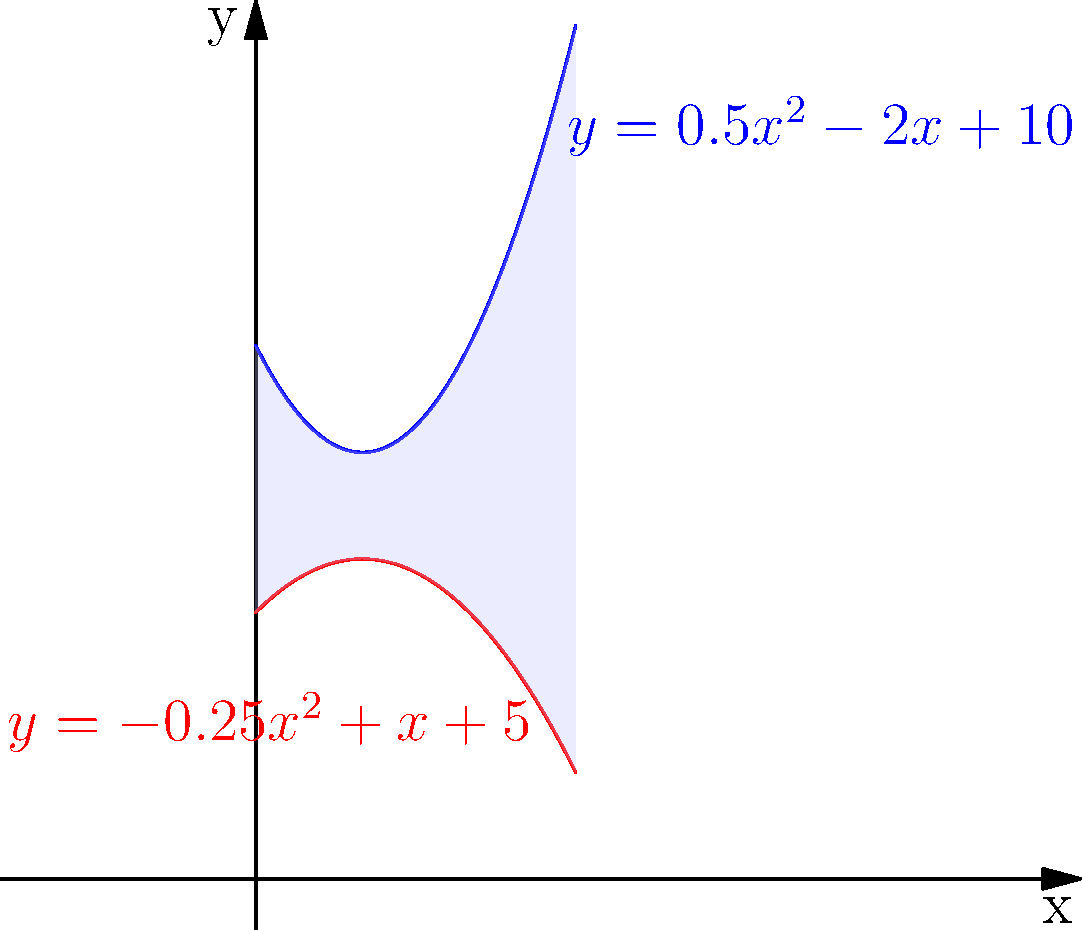The Scone Thistle football pitch has an unusual shape. The groundskeeper measured the width of the pitch at various points along its length and found that it can be modeled by two polynomial functions:

Upper boundary: $y = 0.5x^2 - 2x + 10$
Lower boundary: $y = -0.25x^2 + x + 5$

where $x$ is the distance along the length of the pitch in meters, and $y$ is the half-width of the pitch in meters. If the pitch is 60 meters long, calculate its total area in square meters. To find the area of the pitch, we need to calculate the area between the two curves over the interval $[0, 60]$. This can be done using definite integration.

Step 1: Set up the integral
Area = $\int_0^{60} [(0.5x^2 - 2x + 10) - (-0.25x^2 + x + 5)] dx$

Step 2: Simplify the integrand
$\int_0^{60} (0.5x^2 - 2x + 10 + 0.25x^2 - x - 5) dx$
$= \int_0^{60} (0.75x^2 - 3x + 5) dx$

Step 3: Integrate
$= [0.25x^3 - 1.5x^2 + 5x]_0^{60}$

Step 4: Evaluate the integral
$= (0.25 \cdot 60^3 - 1.5 \cdot 60^2 + 5 \cdot 60) - (0.25 \cdot 0^3 - 1.5 \cdot 0^2 + 5 \cdot 0)$
$= (54000 - 5400 + 300) - 0$
$= 48900$

Therefore, the total area of the Scone Thistle football pitch is 48900 square meters.
Answer: 48900 m² 